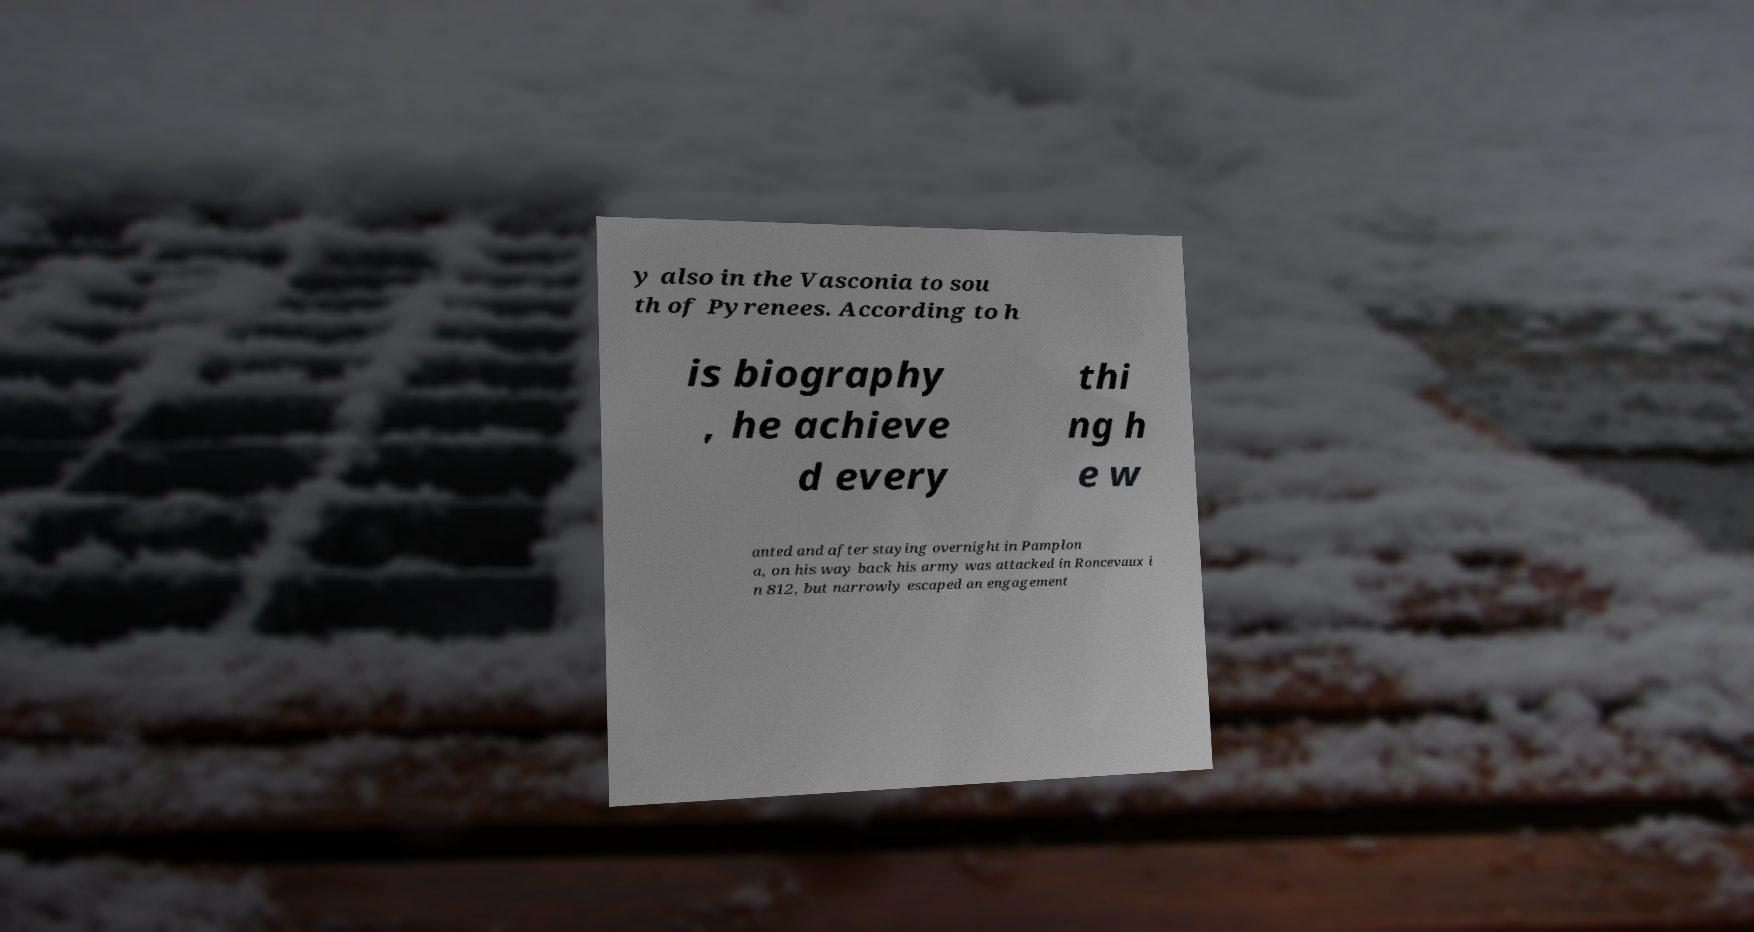Please read and relay the text visible in this image. What does it say? y also in the Vasconia to sou th of Pyrenees. According to h is biography , he achieve d every thi ng h e w anted and after staying overnight in Pamplon a, on his way back his army was attacked in Roncevaux i n 812, but narrowly escaped an engagement 